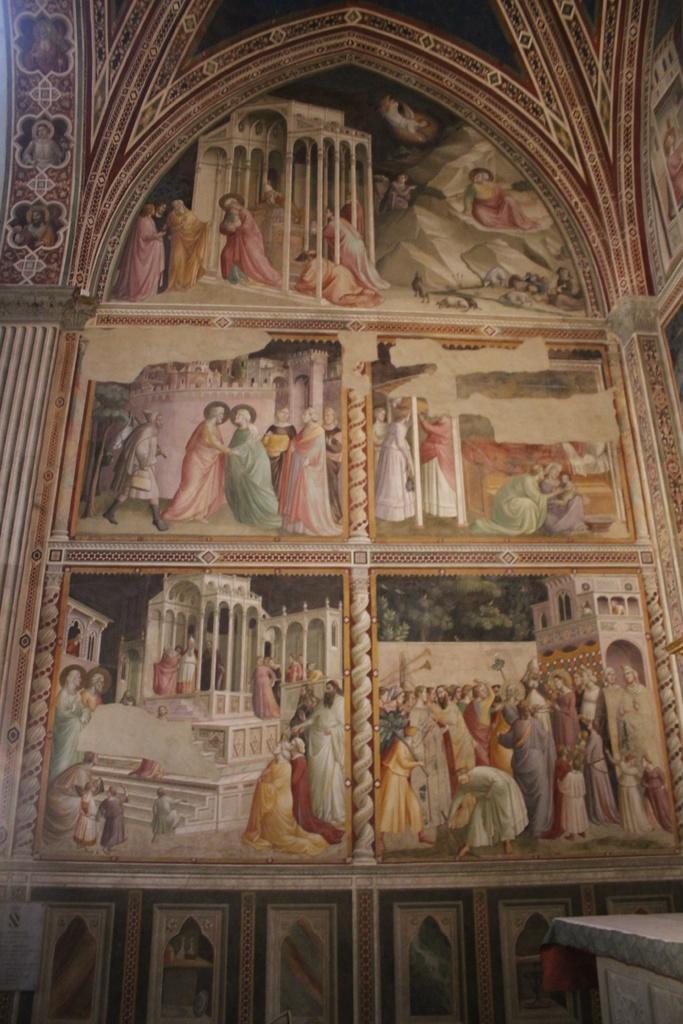Please provide a concise description of this image. In this picture I can see there is a painting of few people on the wall and there is a building and there are pillars in the picture. 